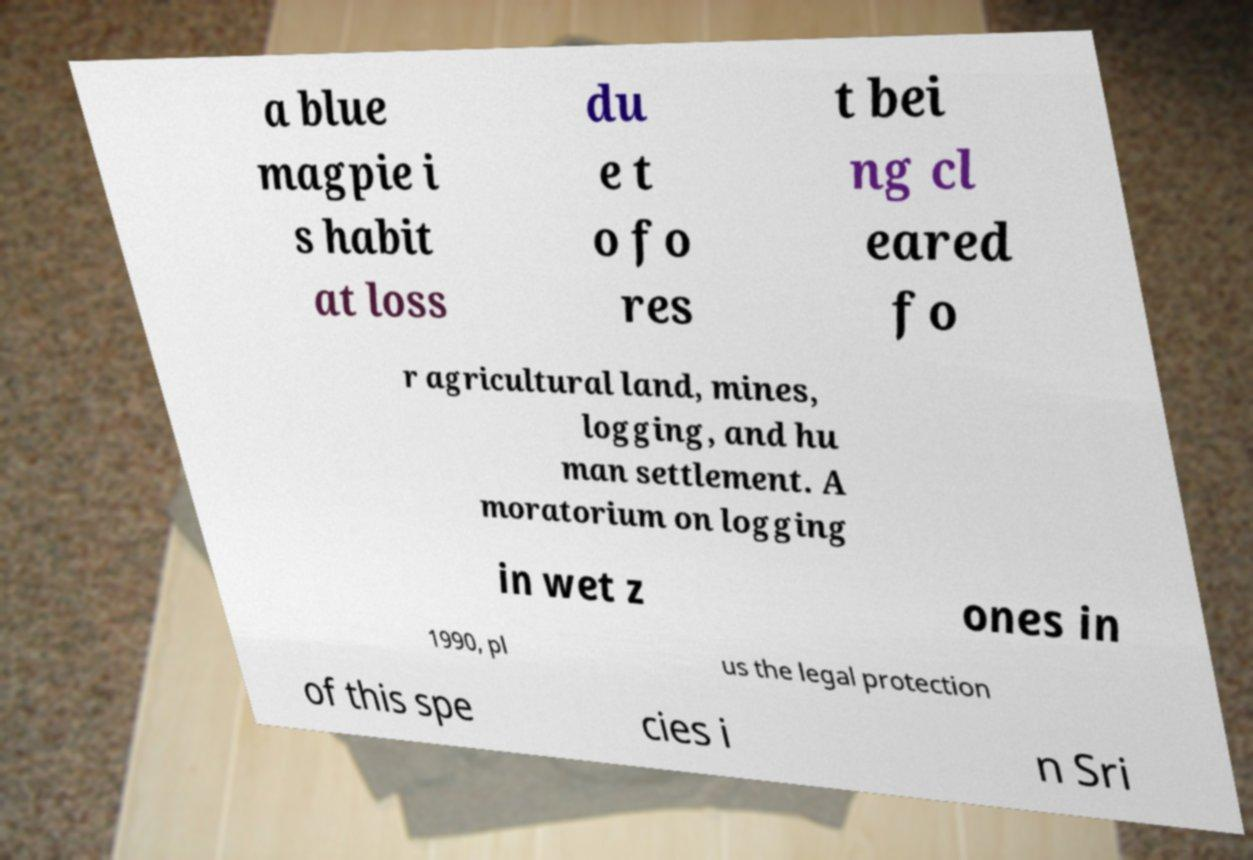What messages or text are displayed in this image? I need them in a readable, typed format. a blue magpie i s habit at loss du e t o fo res t bei ng cl eared fo r agricultural land, mines, logging, and hu man settlement. A moratorium on logging in wet z ones in 1990, pl us the legal protection of this spe cies i n Sri 